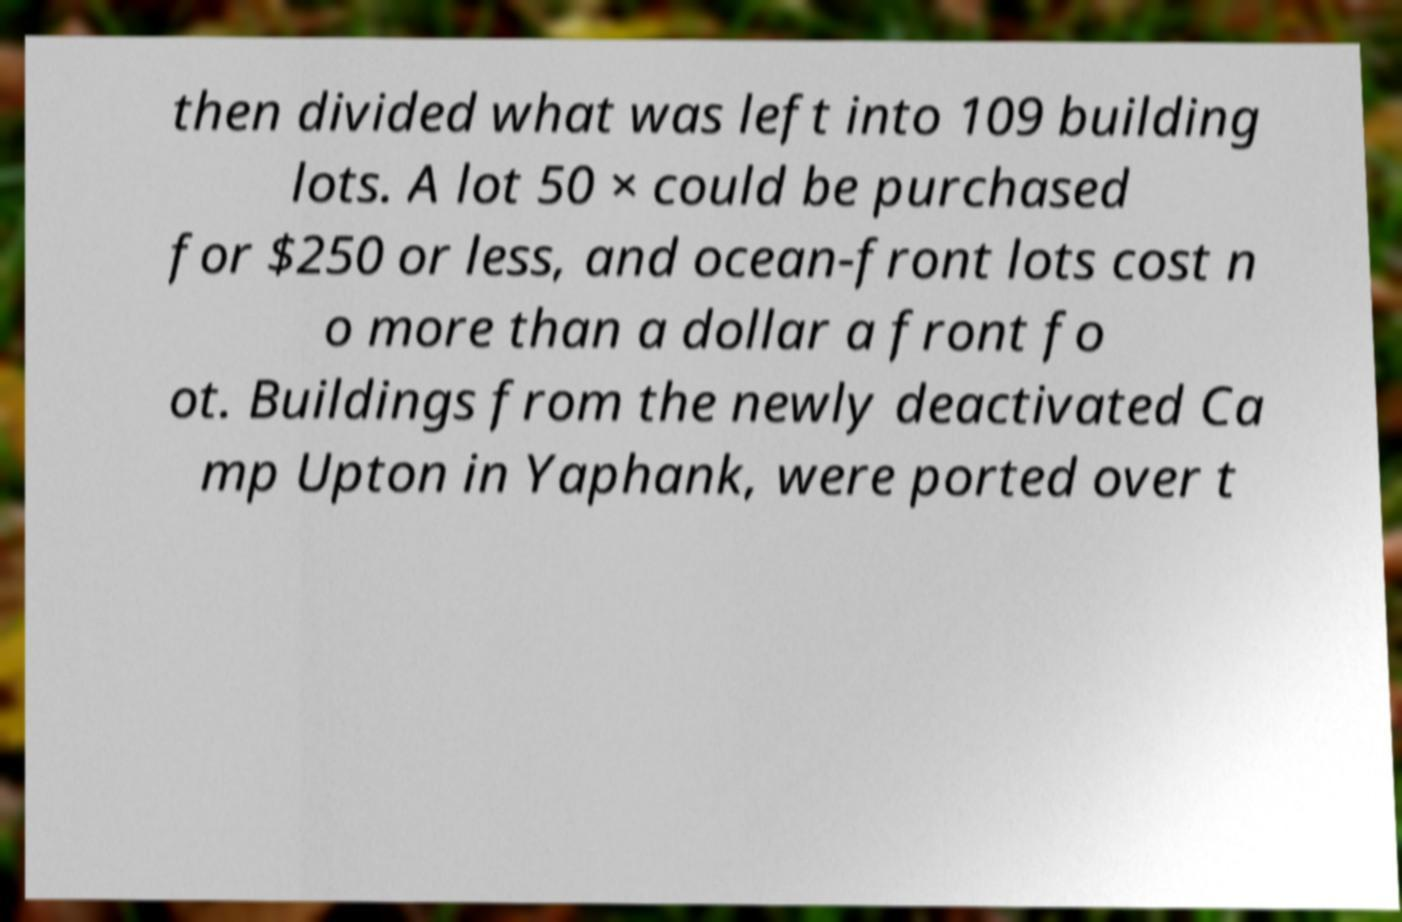Please read and relay the text visible in this image. What does it say? then divided what was left into 109 building lots. A lot 50 × could be purchased for $250 or less, and ocean-front lots cost n o more than a dollar a front fo ot. Buildings from the newly deactivated Ca mp Upton in Yaphank, were ported over t 